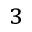<formula> <loc_0><loc_0><loc_500><loc_500>_ { 3 }</formula> 